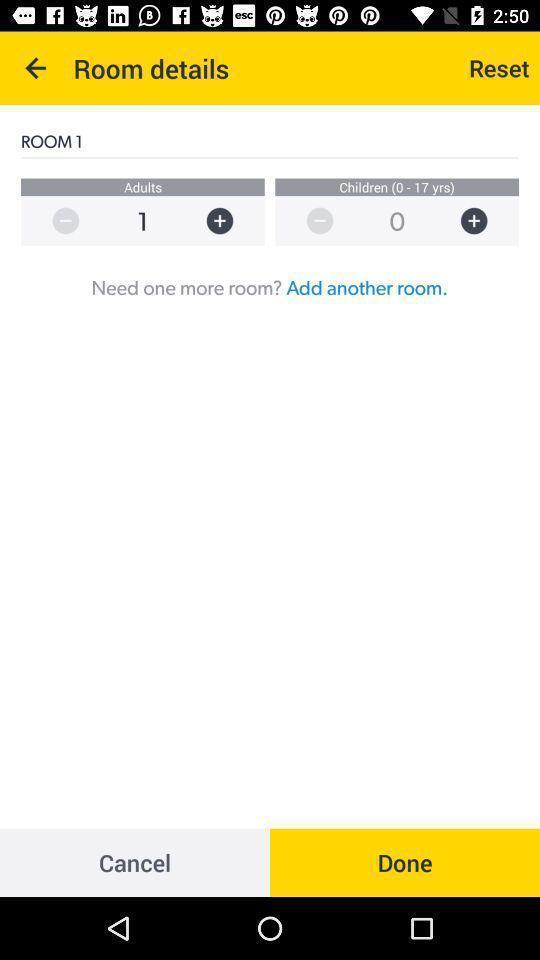Describe this image in words. Screen showing room details. 